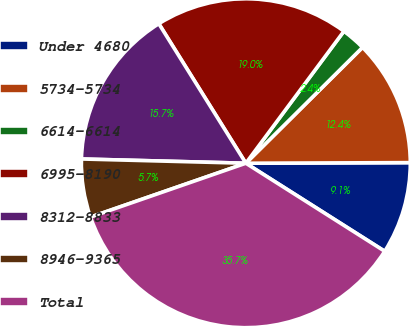Convert chart. <chart><loc_0><loc_0><loc_500><loc_500><pie_chart><fcel>Under 4680<fcel>5734-5734<fcel>6614-6614<fcel>6995-8190<fcel>8312-8833<fcel>8946-9365<fcel>Total<nl><fcel>9.05%<fcel>12.38%<fcel>2.39%<fcel>19.04%<fcel>15.71%<fcel>5.72%<fcel>35.69%<nl></chart> 